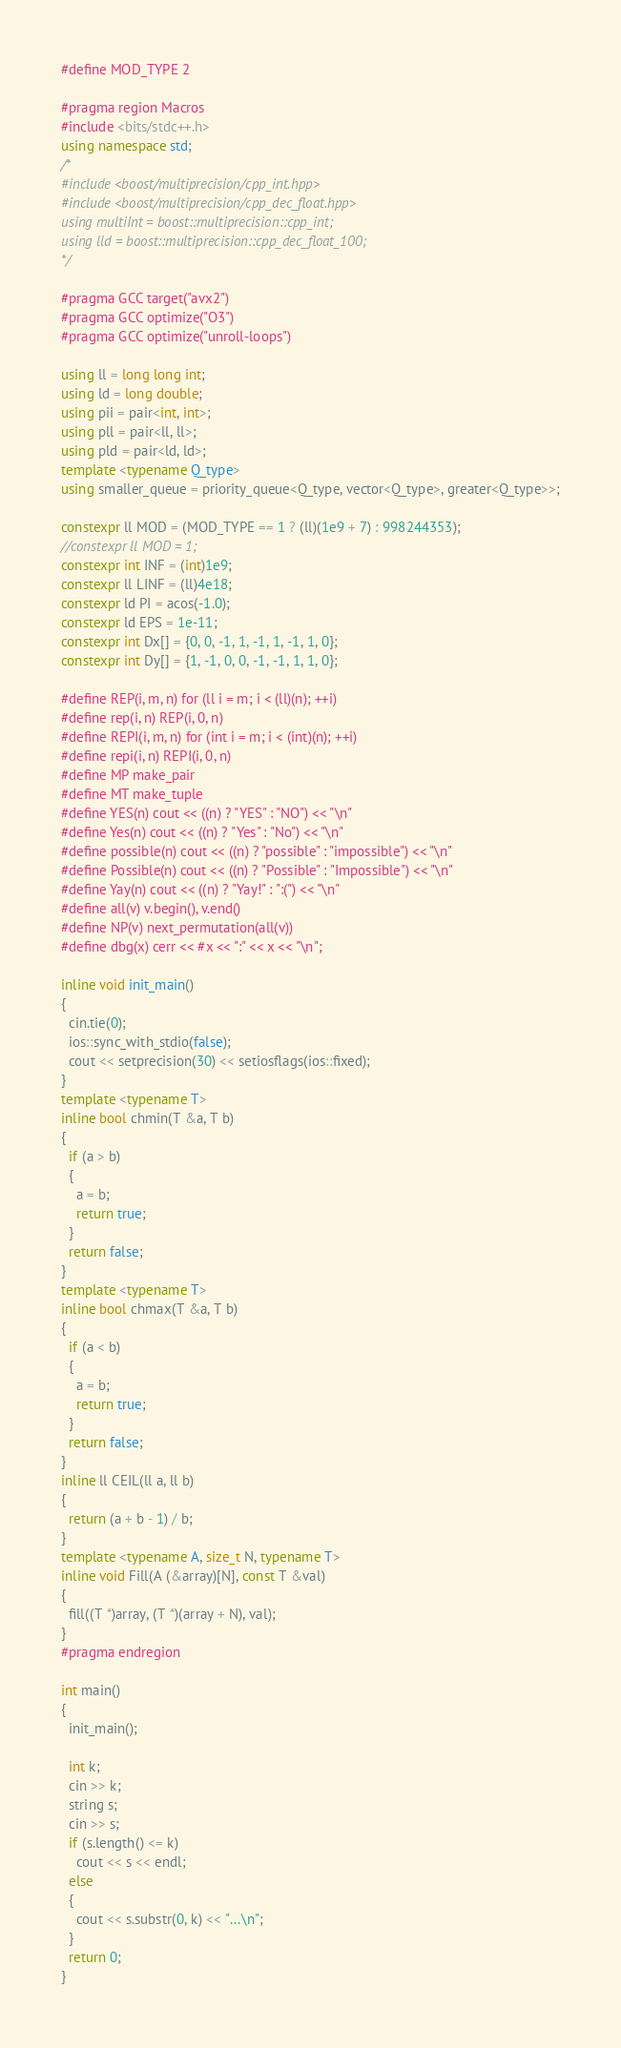Convert code to text. <code><loc_0><loc_0><loc_500><loc_500><_C++_>#define MOD_TYPE 2

#pragma region Macros
#include <bits/stdc++.h>
using namespace std;
/*
#include <boost/multiprecision/cpp_int.hpp>
#include <boost/multiprecision/cpp_dec_float.hpp>
using multiInt = boost::multiprecision::cpp_int;
using lld = boost::multiprecision::cpp_dec_float_100;
*/

#pragma GCC target("avx2")
#pragma GCC optimize("O3")
#pragma GCC optimize("unroll-loops")

using ll = long long int;
using ld = long double;
using pii = pair<int, int>;
using pll = pair<ll, ll>;
using pld = pair<ld, ld>;
template <typename Q_type>
using smaller_queue = priority_queue<Q_type, vector<Q_type>, greater<Q_type>>;

constexpr ll MOD = (MOD_TYPE == 1 ? (ll)(1e9 + 7) : 998244353);
//constexpr ll MOD = 1;
constexpr int INF = (int)1e9;
constexpr ll LINF = (ll)4e18;
constexpr ld PI = acos(-1.0);
constexpr ld EPS = 1e-11;
constexpr int Dx[] = {0, 0, -1, 1, -1, 1, -1, 1, 0};
constexpr int Dy[] = {1, -1, 0, 0, -1, -1, 1, 1, 0};

#define REP(i, m, n) for (ll i = m; i < (ll)(n); ++i)
#define rep(i, n) REP(i, 0, n)
#define REPI(i, m, n) for (int i = m; i < (int)(n); ++i)
#define repi(i, n) REPI(i, 0, n)
#define MP make_pair
#define MT make_tuple
#define YES(n) cout << ((n) ? "YES" : "NO") << "\n"
#define Yes(n) cout << ((n) ? "Yes" : "No") << "\n"
#define possible(n) cout << ((n) ? "possible" : "impossible") << "\n"
#define Possible(n) cout << ((n) ? "Possible" : "Impossible") << "\n"
#define Yay(n) cout << ((n) ? "Yay!" : ":(") << "\n"
#define all(v) v.begin(), v.end()
#define NP(v) next_permutation(all(v))
#define dbg(x) cerr << #x << ":" << x << "\n";

inline void init_main()
{
  cin.tie(0);
  ios::sync_with_stdio(false);
  cout << setprecision(30) << setiosflags(ios::fixed);
}
template <typename T>
inline bool chmin(T &a, T b)
{
  if (a > b)
  {
    a = b;
    return true;
  }
  return false;
}
template <typename T>
inline bool chmax(T &a, T b)
{
  if (a < b)
  {
    a = b;
    return true;
  }
  return false;
}
inline ll CEIL(ll a, ll b)
{
  return (a + b - 1) / b;
}
template <typename A, size_t N, typename T>
inline void Fill(A (&array)[N], const T &val)
{
  fill((T *)array, (T *)(array + N), val);
}
#pragma endregion

int main()
{
  init_main();

  int k;
  cin >> k;
  string s;
  cin >> s;
  if (s.length() <= k)
    cout << s << endl;
  else
  {
    cout << s.substr(0, k) << "...\n";
  }
  return 0;
}</code> 